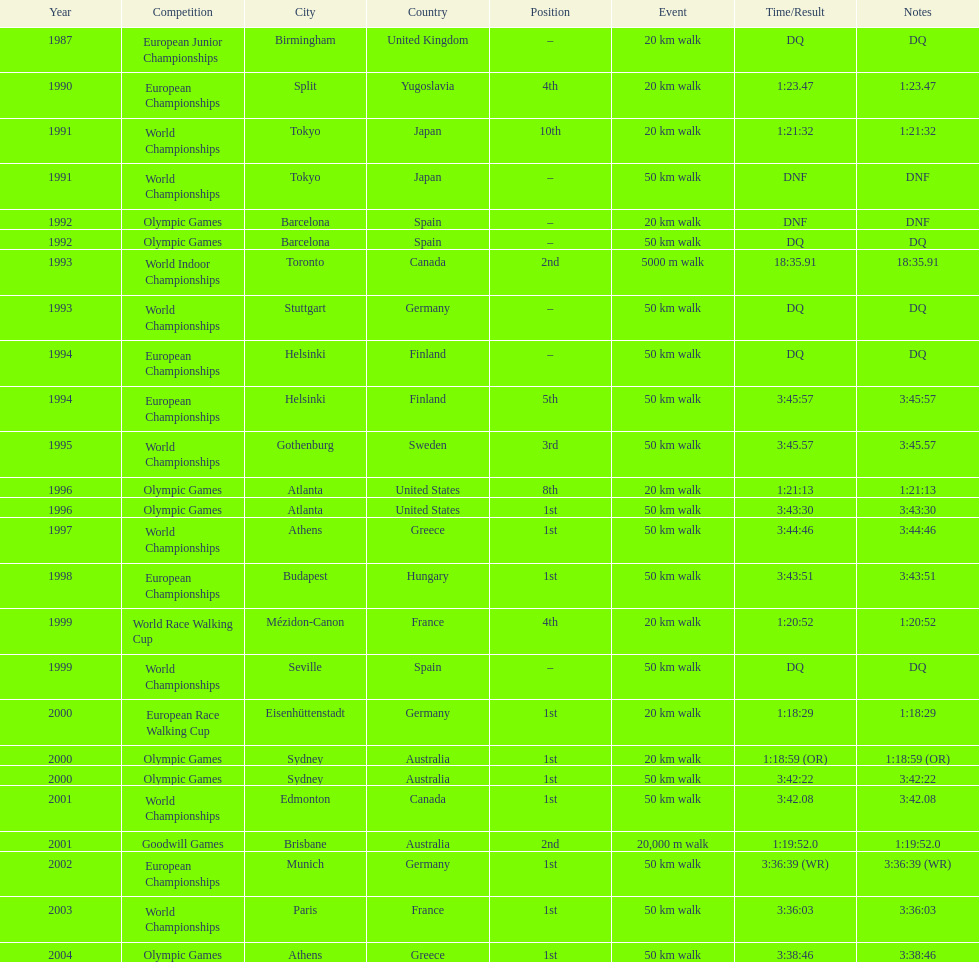How long did it take to walk 50 km in the 2004 olympic games? 3:38:46. 